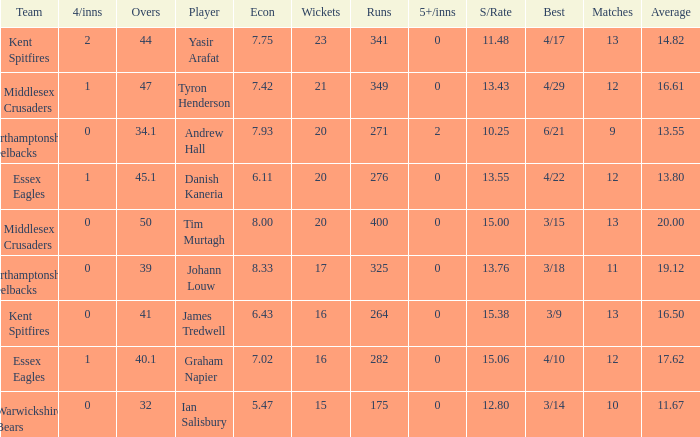Name the matches for wickets 17 11.0. 